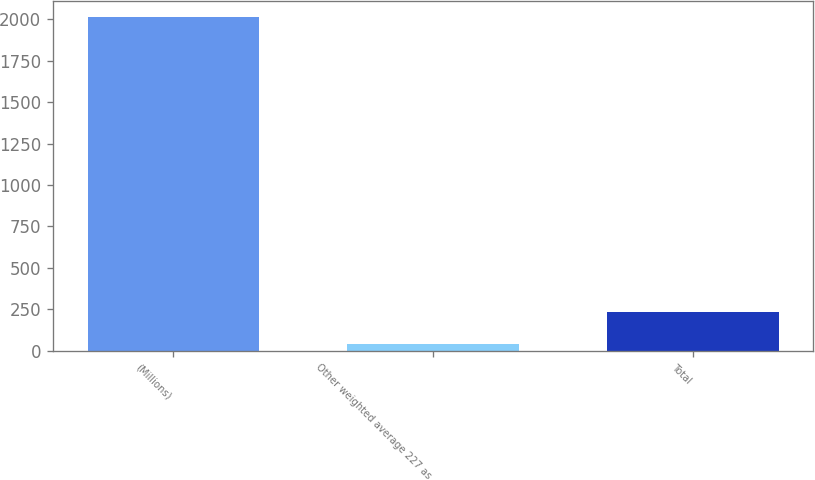<chart> <loc_0><loc_0><loc_500><loc_500><bar_chart><fcel>(Millions)<fcel>Other weighted average 227 as<fcel>Total<nl><fcel>2012<fcel>39<fcel>236.3<nl></chart> 